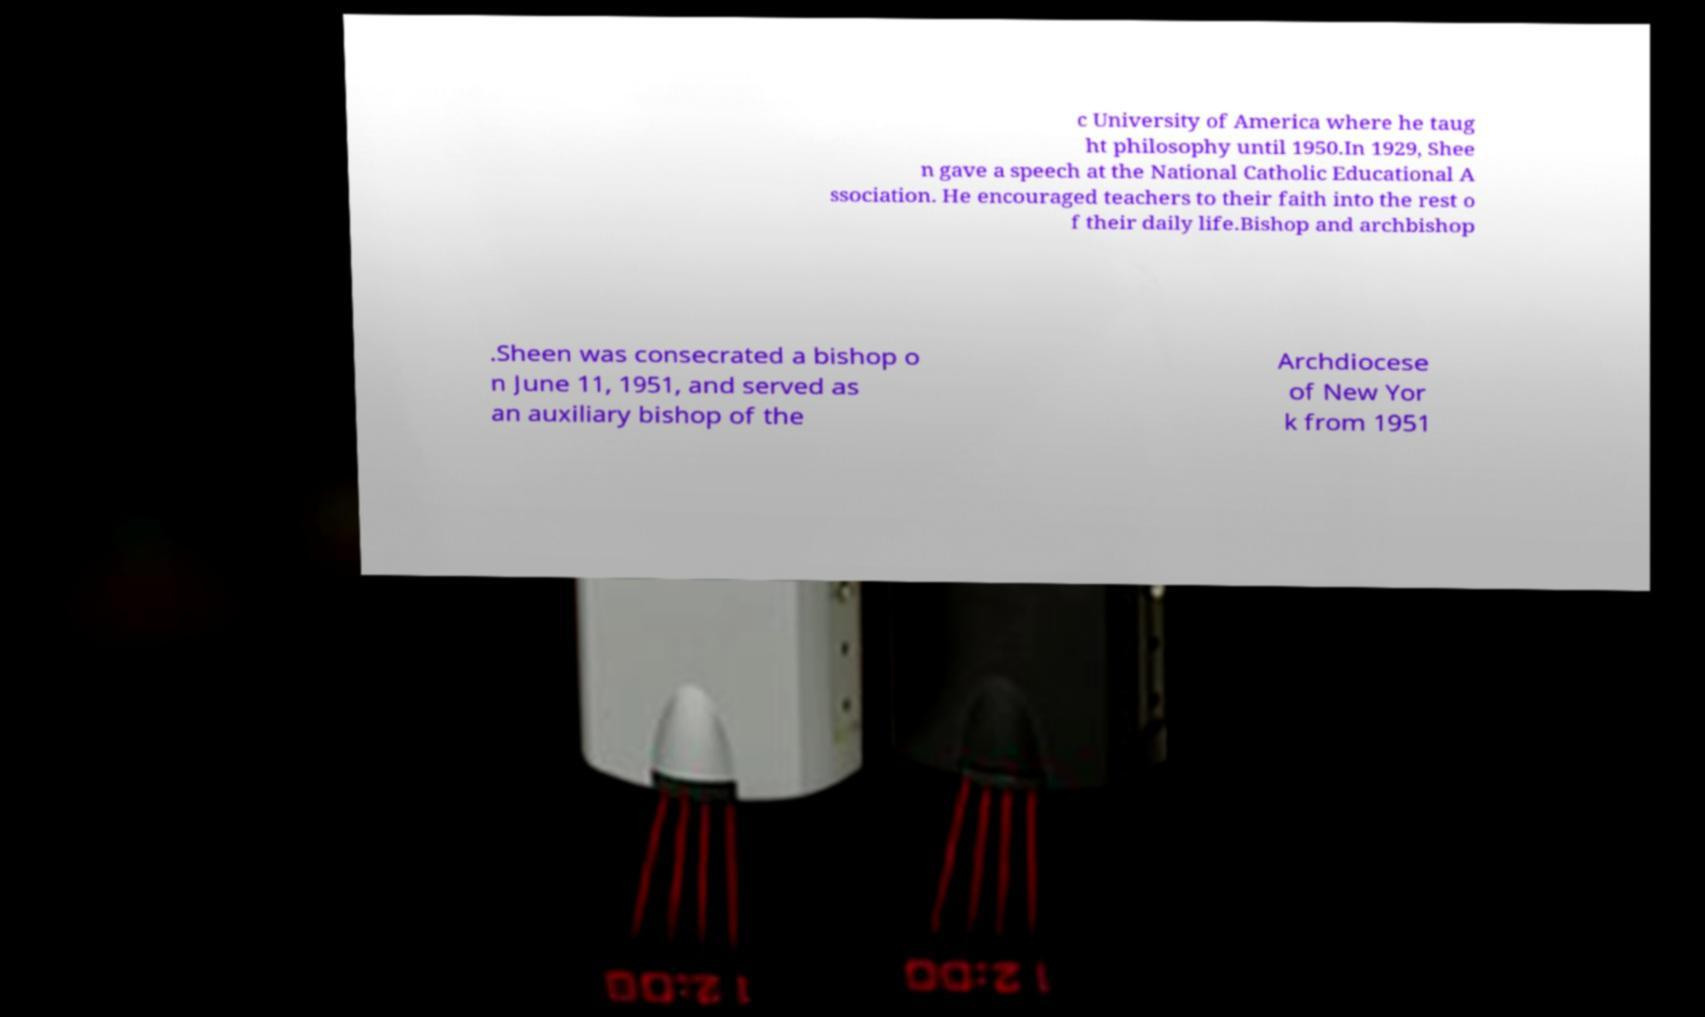What messages or text are displayed in this image? I need them in a readable, typed format. c University of America where he taug ht philosophy until 1950.In 1929, Shee n gave a speech at the National Catholic Educational A ssociation. He encouraged teachers to their faith into the rest o f their daily life.Bishop and archbishop .Sheen was consecrated a bishop o n June 11, 1951, and served as an auxiliary bishop of the Archdiocese of New Yor k from 1951 